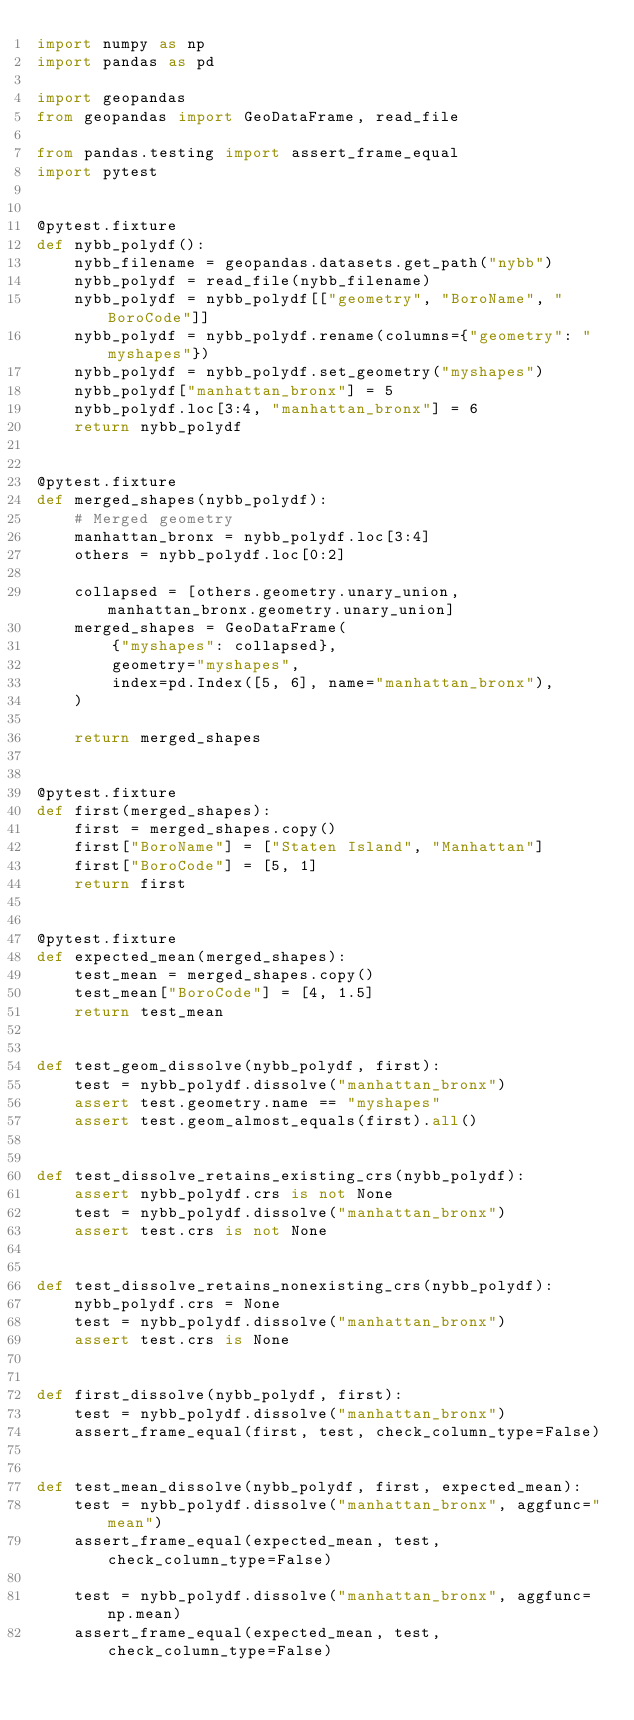<code> <loc_0><loc_0><loc_500><loc_500><_Python_>import numpy as np
import pandas as pd

import geopandas
from geopandas import GeoDataFrame, read_file

from pandas.testing import assert_frame_equal
import pytest


@pytest.fixture
def nybb_polydf():
    nybb_filename = geopandas.datasets.get_path("nybb")
    nybb_polydf = read_file(nybb_filename)
    nybb_polydf = nybb_polydf[["geometry", "BoroName", "BoroCode"]]
    nybb_polydf = nybb_polydf.rename(columns={"geometry": "myshapes"})
    nybb_polydf = nybb_polydf.set_geometry("myshapes")
    nybb_polydf["manhattan_bronx"] = 5
    nybb_polydf.loc[3:4, "manhattan_bronx"] = 6
    return nybb_polydf


@pytest.fixture
def merged_shapes(nybb_polydf):
    # Merged geometry
    manhattan_bronx = nybb_polydf.loc[3:4]
    others = nybb_polydf.loc[0:2]

    collapsed = [others.geometry.unary_union, manhattan_bronx.geometry.unary_union]
    merged_shapes = GeoDataFrame(
        {"myshapes": collapsed},
        geometry="myshapes",
        index=pd.Index([5, 6], name="manhattan_bronx"),
    )

    return merged_shapes


@pytest.fixture
def first(merged_shapes):
    first = merged_shapes.copy()
    first["BoroName"] = ["Staten Island", "Manhattan"]
    first["BoroCode"] = [5, 1]
    return first


@pytest.fixture
def expected_mean(merged_shapes):
    test_mean = merged_shapes.copy()
    test_mean["BoroCode"] = [4, 1.5]
    return test_mean


def test_geom_dissolve(nybb_polydf, first):
    test = nybb_polydf.dissolve("manhattan_bronx")
    assert test.geometry.name == "myshapes"
    assert test.geom_almost_equals(first).all()


def test_dissolve_retains_existing_crs(nybb_polydf):
    assert nybb_polydf.crs is not None
    test = nybb_polydf.dissolve("manhattan_bronx")
    assert test.crs is not None


def test_dissolve_retains_nonexisting_crs(nybb_polydf):
    nybb_polydf.crs = None
    test = nybb_polydf.dissolve("manhattan_bronx")
    assert test.crs is None


def first_dissolve(nybb_polydf, first):
    test = nybb_polydf.dissolve("manhattan_bronx")
    assert_frame_equal(first, test, check_column_type=False)


def test_mean_dissolve(nybb_polydf, first, expected_mean):
    test = nybb_polydf.dissolve("manhattan_bronx", aggfunc="mean")
    assert_frame_equal(expected_mean, test, check_column_type=False)

    test = nybb_polydf.dissolve("manhattan_bronx", aggfunc=np.mean)
    assert_frame_equal(expected_mean, test, check_column_type=False)

</code> 